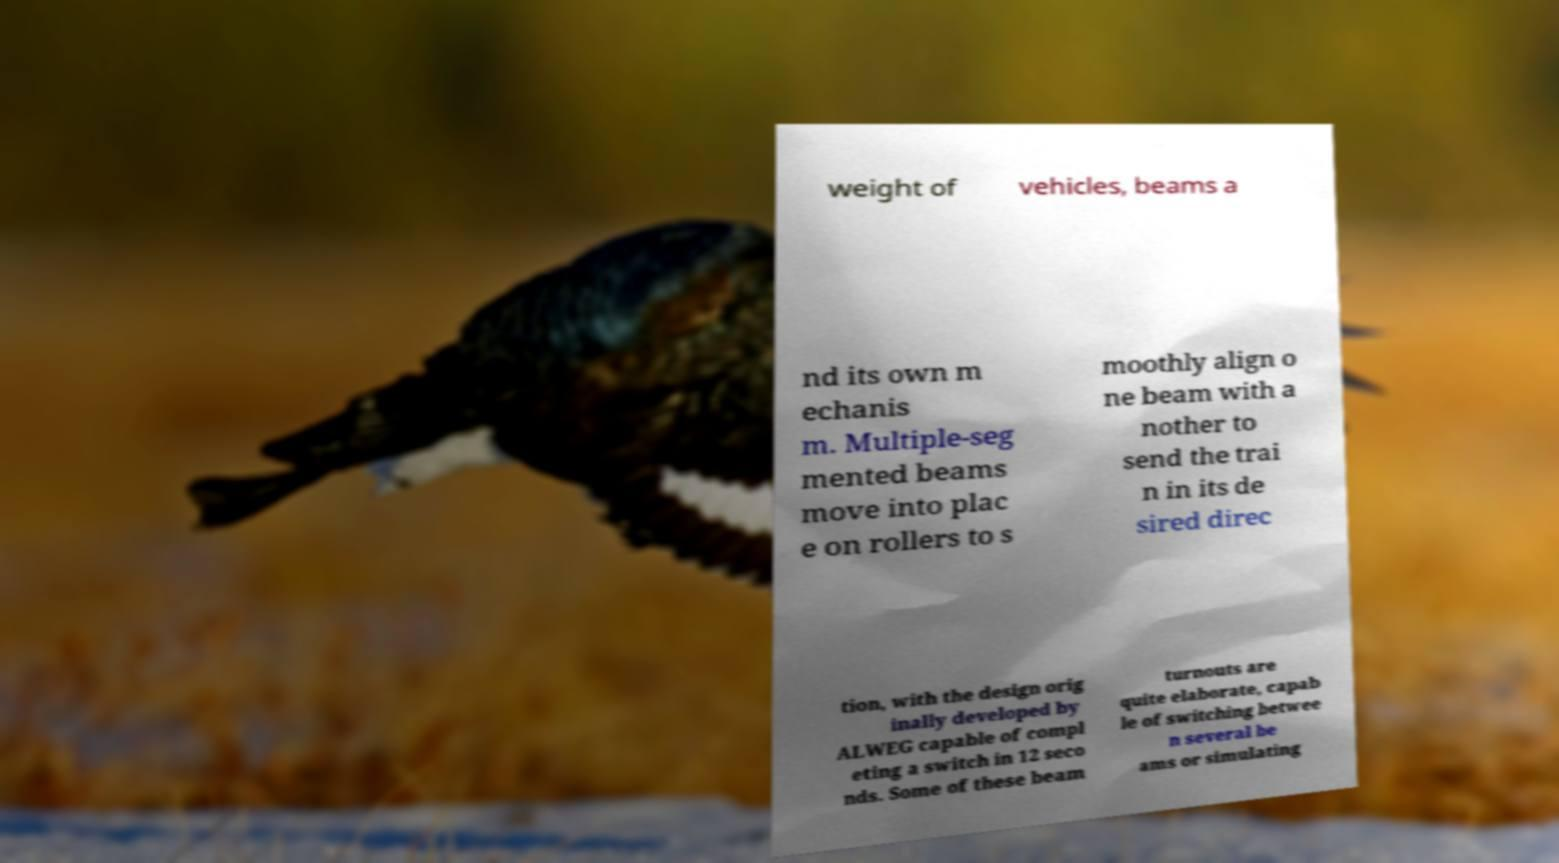Could you extract and type out the text from this image? weight of vehicles, beams a nd its own m echanis m. Multiple-seg mented beams move into plac e on rollers to s moothly align o ne beam with a nother to send the trai n in its de sired direc tion, with the design orig inally developed by ALWEG capable of compl eting a switch in 12 seco nds. Some of these beam turnouts are quite elaborate, capab le of switching betwee n several be ams or simulating 